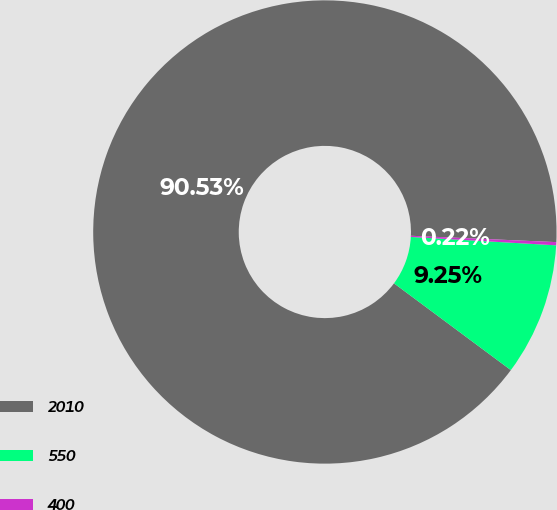Convert chart to OTSL. <chart><loc_0><loc_0><loc_500><loc_500><pie_chart><fcel>2010<fcel>550<fcel>400<nl><fcel>90.53%<fcel>9.25%<fcel>0.22%<nl></chart> 